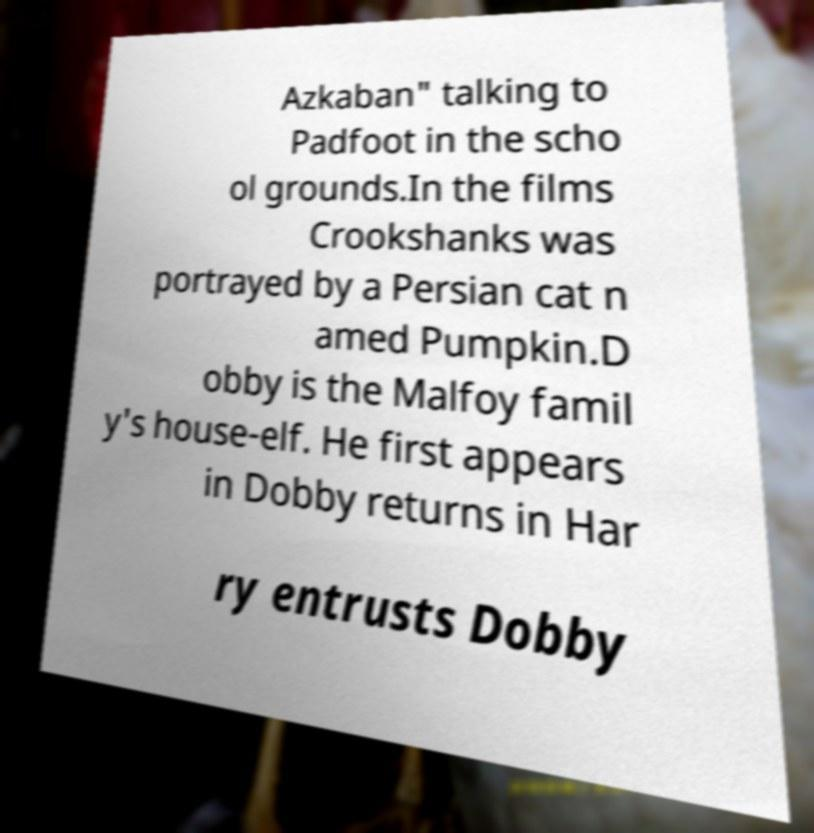Please read and relay the text visible in this image. What does it say? Azkaban" talking to Padfoot in the scho ol grounds.In the films Crookshanks was portrayed by a Persian cat n amed Pumpkin.D obby is the Malfoy famil y's house-elf. He first appears in Dobby returns in Har ry entrusts Dobby 